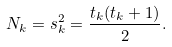Convert formula to latex. <formula><loc_0><loc_0><loc_500><loc_500>N _ { k } = s _ { k } ^ { 2 } = { \frac { t _ { k } ( t _ { k } + 1 ) } { 2 } } .</formula> 